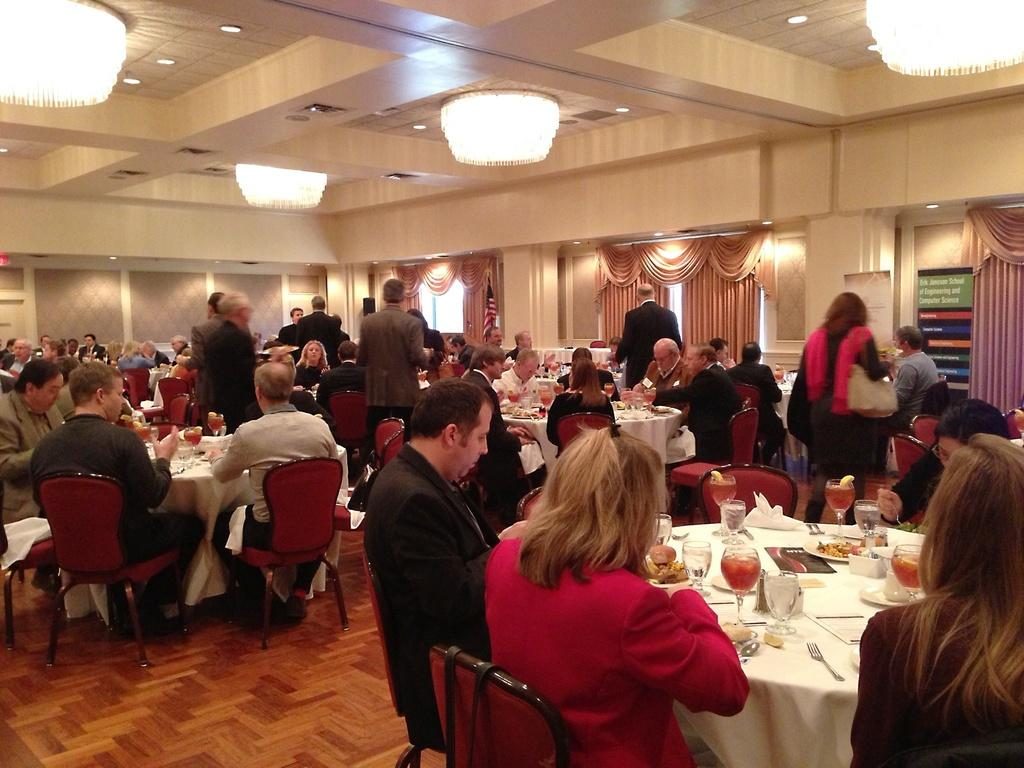What type of setting is depicted in the image? The image appears to depict a restaurant setting. What activities are the people likely engaged in? The people present are likely engaged in eating. What type of furniture is visible in the image? Chairs and tables are visible in the image. What else can be seen in the image besides furniture? Food and drinks are present in the image. How many kittens are sitting on the branch in the image? There are no kittens or branches present in the image. What is the message of the good-bye note left on the table? There is no good-bye note present in the image. 